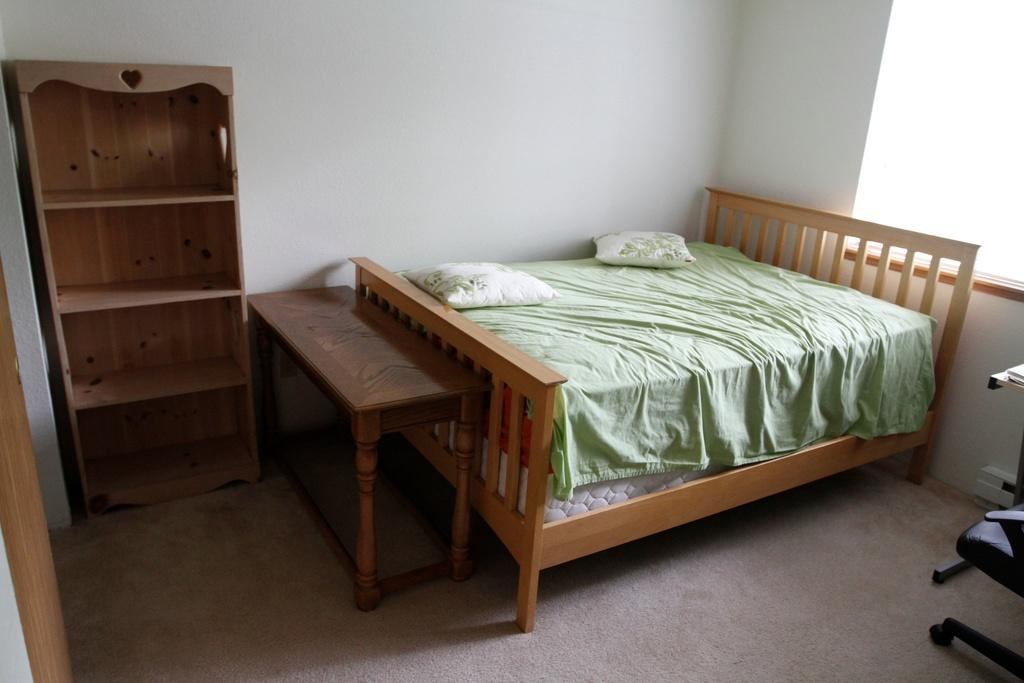What type of space is shown in the image? The image is an inside view of a room. What furniture can be seen in the room? There is a rack stand, a bed, and a chair on the floor in the room. What is on the bed? There are pillows on the bed. How can light enter the room? There is a window in the room. What is the primary structure surrounding the room? There is a wall in the room. Are there any objects visible in the room? Yes, there are objects visible in the room. What type of spark can be seen coming from the sofa in the image? There is no sofa present in the image, so no spark can be seen coming from it. What type of coal is used to heat the room in the image? There is no mention of coal or any heating element in the image, so it cannot be determined from the image. 